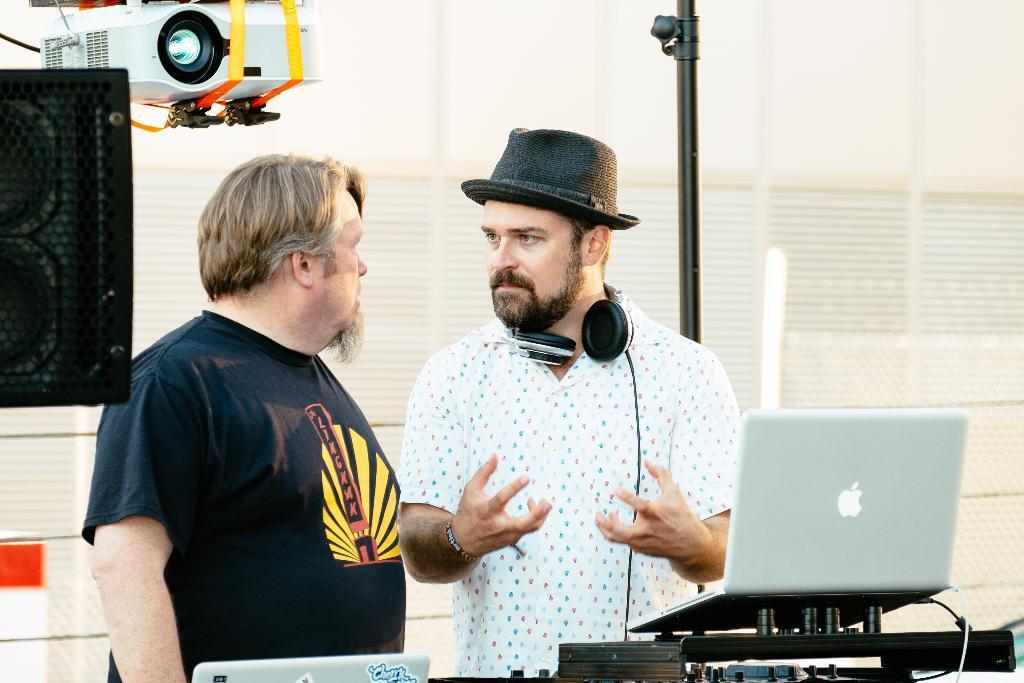Describe this image in one or two sentences. In this image I can see two men are standing in the centre and in the front of them I can see few laptops. I can see the left one is wearing black colour t shirt and the right one is wearing white shirt, black hat and around his neck I can see a headphone. On the right side of this image I can see a speaker and a projector machine. I can also see a pole in the background. 